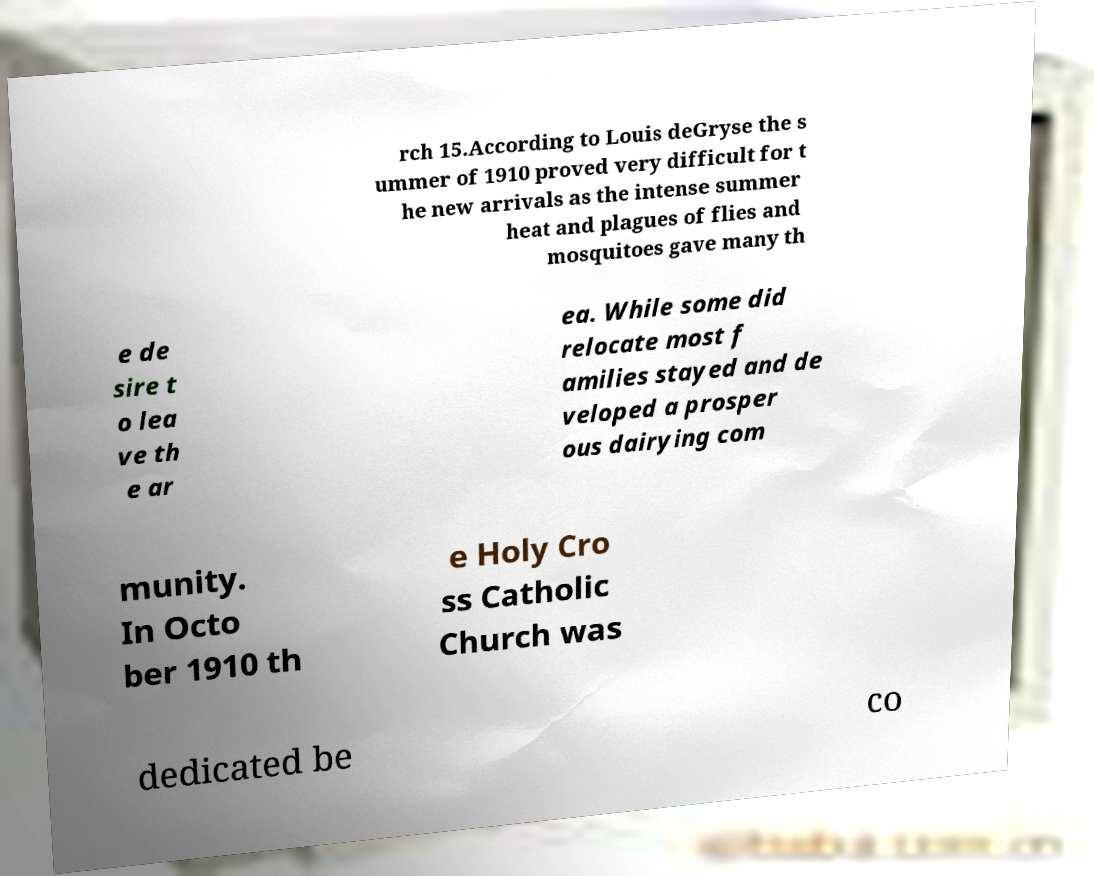Could you extract and type out the text from this image? rch 15.According to Louis deGryse the s ummer of 1910 proved very difficult for t he new arrivals as the intense summer heat and plagues of flies and mosquitoes gave many th e de sire t o lea ve th e ar ea. While some did relocate most f amilies stayed and de veloped a prosper ous dairying com munity. In Octo ber 1910 th e Holy Cro ss Catholic Church was dedicated be co 